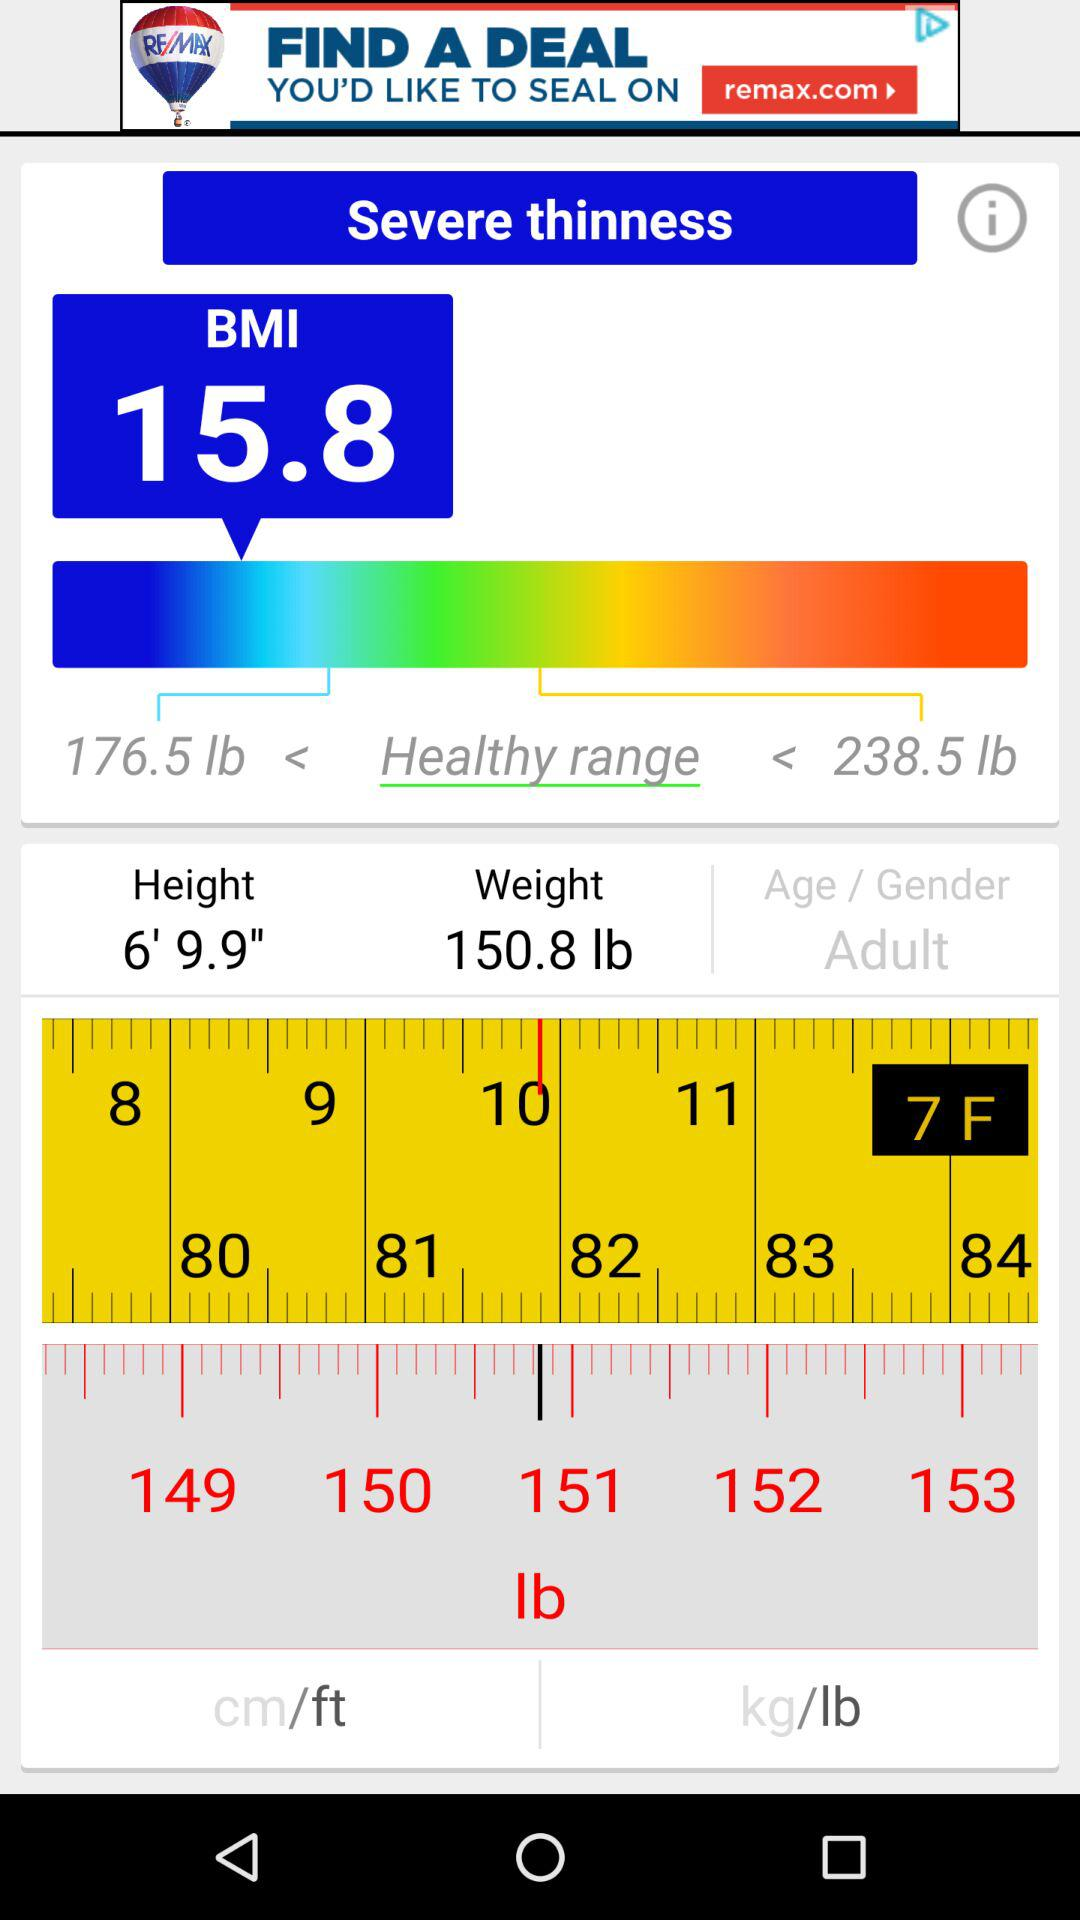What is the healthy range? The healthy range is greater than 176.5 pounds and less than 238.5 pounds. 